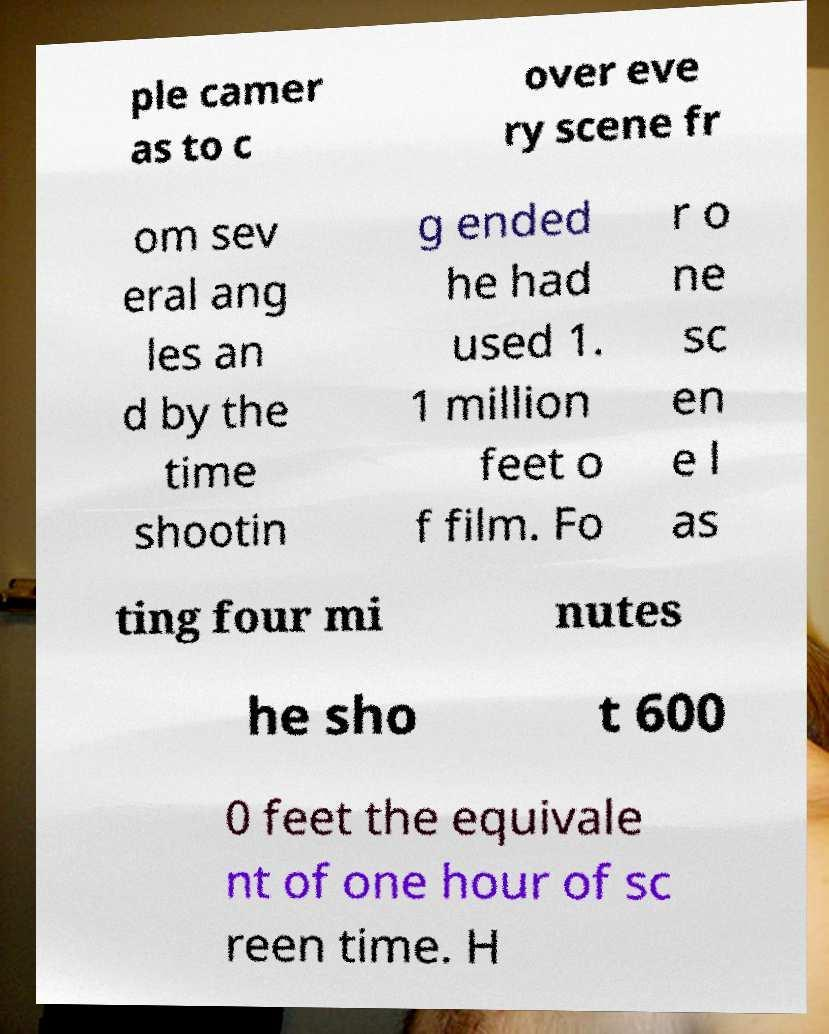Please identify and transcribe the text found in this image. ple camer as to c over eve ry scene fr om sev eral ang les an d by the time shootin g ended he had used 1. 1 million feet o f film. Fo r o ne sc en e l as ting four mi nutes he sho t 600 0 feet the equivale nt of one hour of sc reen time. H 